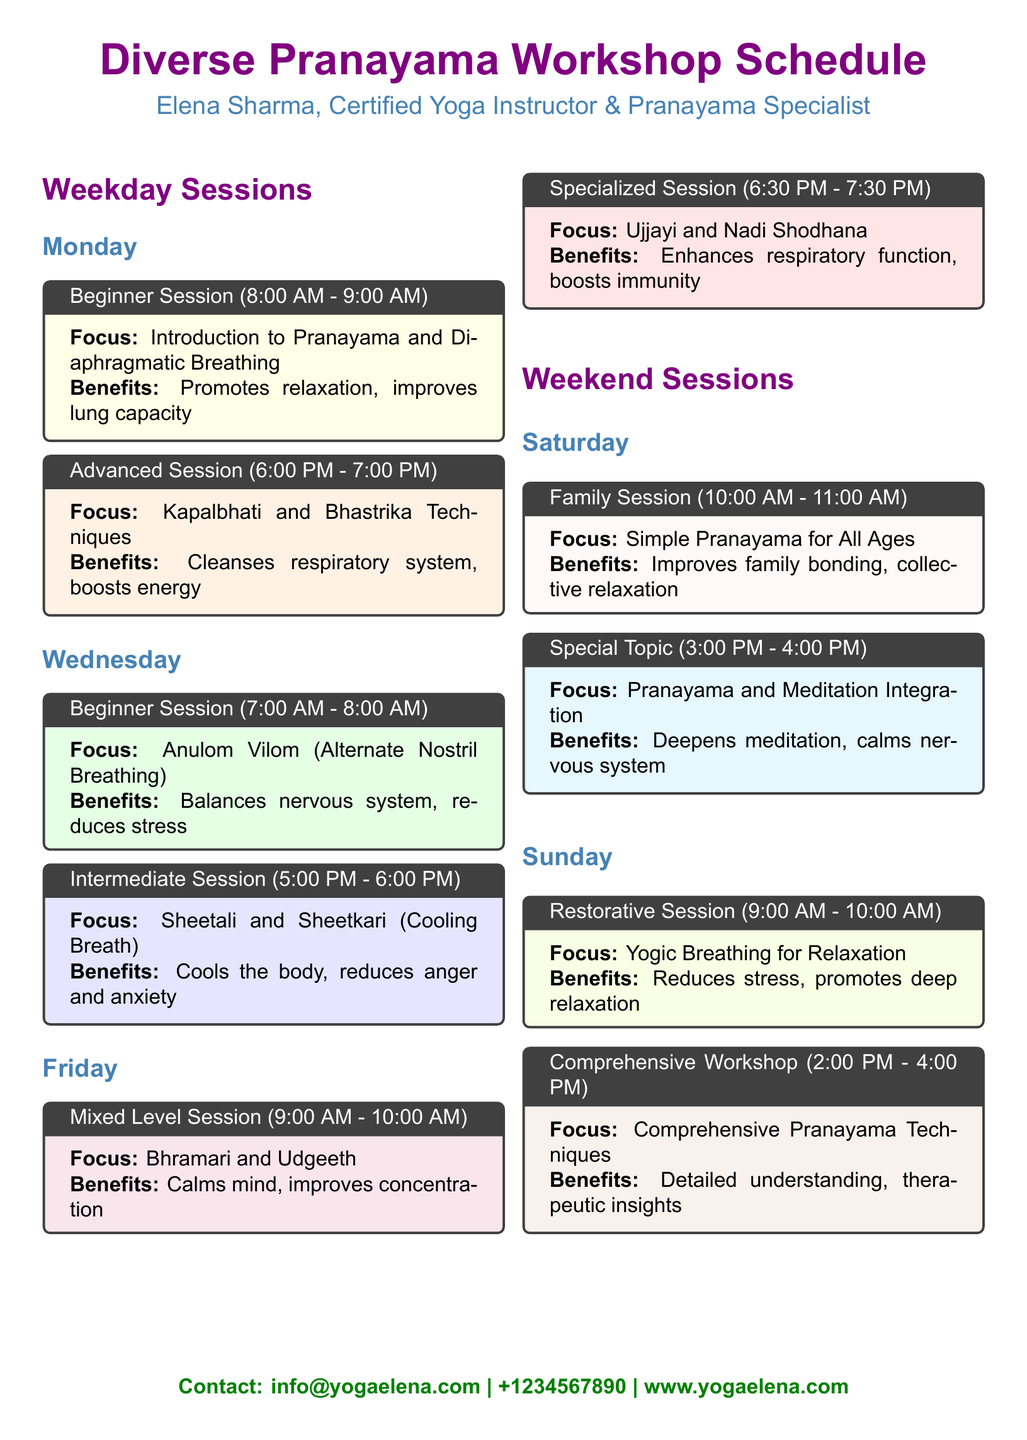What is the focus of the Beginner Session on Monday? The focus is specified in the box for the Beginner Session on Monday, which states, "Introduction to Pranayama and Diaphragmatic Breathing."
Answer: Introduction to Pranayama and Diaphragmatic Breathing What time does the Advanced Session on Monday start? The start time of the Advanced Session is mentioned in the title box, which states that it is from "6:00 PM - 7:00 PM."
Answer: 6:00 PM What are the benefits of Anulom Vilom? The benefits are detailed in the box for the Beginner Session on Wednesday, which states it "Balances nervous system, reduces stress."
Answer: Balances nervous system, reduces stress How long is the Comprehensive Workshop on Sunday? The duration is specified in the title box, indicating it lasts "2:00 PM - 4:00 PM," which is a total of 2 hours.
Answer: 2 hours Which session focuses on breathing techniques for family? The session designed for family bonding is titled "Family Session," mentioned on Saturday.
Answer: Family Session On which day is the Restorative Session held? The Restorative Session is listed under Sunday in the schedule, indicating its occurrence on that day.
Answer: Sunday What color represents the Specialized Session on Friday? The color used for the box of the Specialized Session is specified, which is "red."
Answer: Red What is the contact email provided in the document? The contact email can be found in the bottom section of the document stating "info@yogaelena.com."
Answer: info@yogaelena.com What type of session is scheduled at 3:00 PM on Saturday? The session is categorized as a "Special Topic," focusing on the integration of Pranayama and meditation.
Answer: Special Topic 